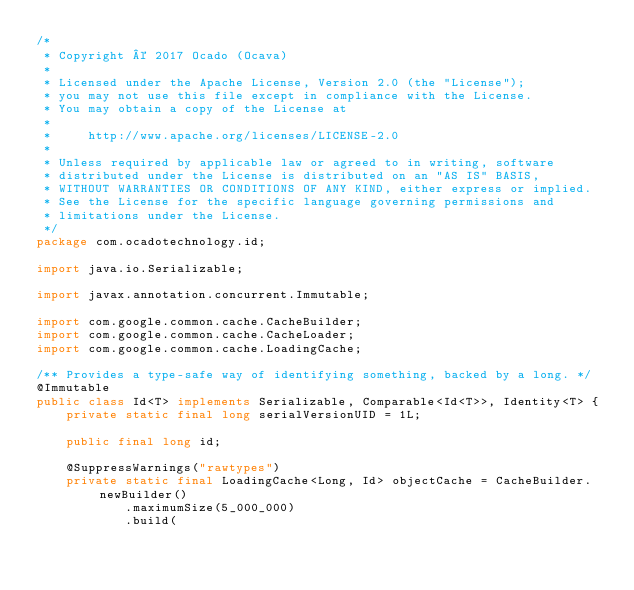Convert code to text. <code><loc_0><loc_0><loc_500><loc_500><_Java_>/*
 * Copyright © 2017 Ocado (Ocava)
 *
 * Licensed under the Apache License, Version 2.0 (the "License");
 * you may not use this file except in compliance with the License.
 * You may obtain a copy of the License at
 *
 *     http://www.apache.org/licenses/LICENSE-2.0
 *
 * Unless required by applicable law or agreed to in writing, software
 * distributed under the License is distributed on an "AS IS" BASIS,
 * WITHOUT WARRANTIES OR CONDITIONS OF ANY KIND, either express or implied.
 * See the License for the specific language governing permissions and
 * limitations under the License.
 */
package com.ocadotechnology.id;

import java.io.Serializable;

import javax.annotation.concurrent.Immutable;

import com.google.common.cache.CacheBuilder;
import com.google.common.cache.CacheLoader;
import com.google.common.cache.LoadingCache;

/** Provides a type-safe way of identifying something, backed by a long. */
@Immutable
public class Id<T> implements Serializable, Comparable<Id<T>>, Identity<T> {
    private static final long serialVersionUID = 1L;

    public final long id;

    @SuppressWarnings("rawtypes")
    private static final LoadingCache<Long, Id> objectCache = CacheBuilder.newBuilder()
            .maximumSize(5_000_000)
            .build(</code> 